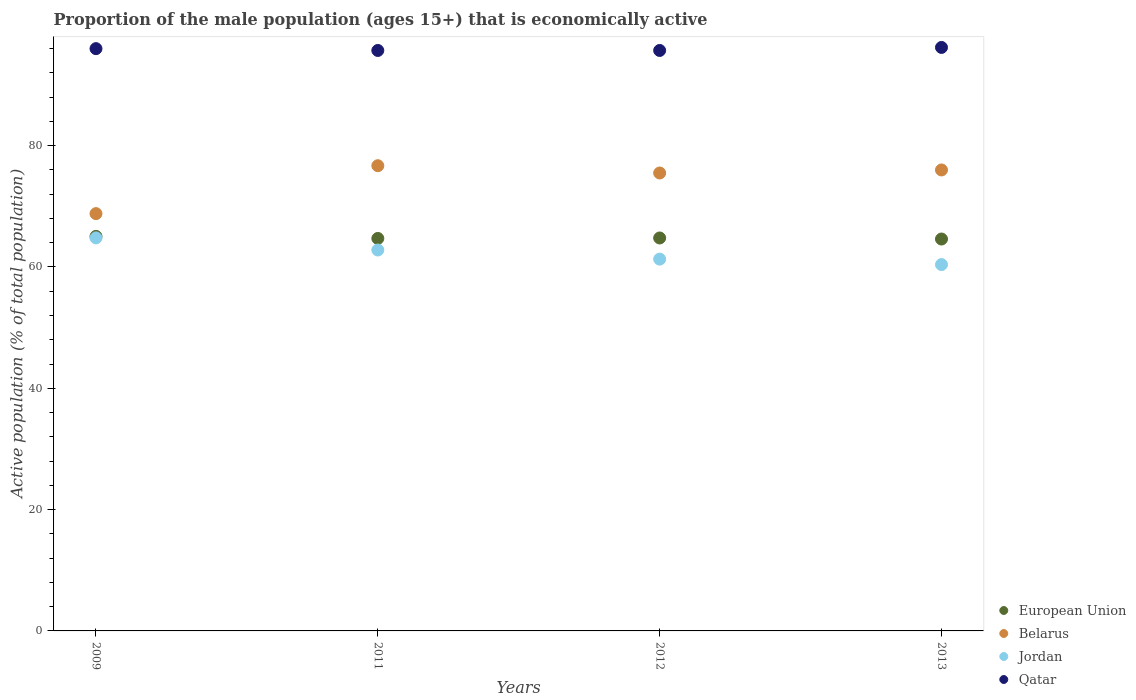How many different coloured dotlines are there?
Offer a terse response. 4. What is the proportion of the male population that is economically active in European Union in 2009?
Provide a succinct answer. 65.04. Across all years, what is the maximum proportion of the male population that is economically active in European Union?
Keep it short and to the point. 65.04. Across all years, what is the minimum proportion of the male population that is economically active in Qatar?
Provide a short and direct response. 95.7. What is the total proportion of the male population that is economically active in Jordan in the graph?
Provide a succinct answer. 249.3. What is the difference between the proportion of the male population that is economically active in Qatar in 2009 and that in 2011?
Your answer should be very brief. 0.3. What is the difference between the proportion of the male population that is economically active in Jordan in 2011 and the proportion of the male population that is economically active in European Union in 2009?
Provide a short and direct response. -2.24. What is the average proportion of the male population that is economically active in Belarus per year?
Provide a succinct answer. 74.25. In the year 2012, what is the difference between the proportion of the male population that is economically active in Qatar and proportion of the male population that is economically active in European Union?
Your answer should be compact. 30.92. What is the ratio of the proportion of the male population that is economically active in Qatar in 2011 to that in 2013?
Ensure brevity in your answer.  0.99. Is the difference between the proportion of the male population that is economically active in Qatar in 2011 and 2013 greater than the difference between the proportion of the male population that is economically active in European Union in 2011 and 2013?
Give a very brief answer. No. What is the difference between the highest and the second highest proportion of the male population that is economically active in European Union?
Offer a terse response. 0.26. What is the difference between the highest and the lowest proportion of the male population that is economically active in Jordan?
Your answer should be very brief. 4.4. Is it the case that in every year, the sum of the proportion of the male population that is economically active in European Union and proportion of the male population that is economically active in Belarus  is greater than the proportion of the male population that is economically active in Jordan?
Make the answer very short. Yes. Does the proportion of the male population that is economically active in European Union monotonically increase over the years?
Make the answer very short. No. Is the proportion of the male population that is economically active in Qatar strictly greater than the proportion of the male population that is economically active in European Union over the years?
Ensure brevity in your answer.  Yes. Is the proportion of the male population that is economically active in European Union strictly less than the proportion of the male population that is economically active in Qatar over the years?
Ensure brevity in your answer.  Yes. How many dotlines are there?
Offer a terse response. 4. How many years are there in the graph?
Provide a short and direct response. 4. Does the graph contain any zero values?
Provide a succinct answer. No. Where does the legend appear in the graph?
Keep it short and to the point. Bottom right. How many legend labels are there?
Make the answer very short. 4. How are the legend labels stacked?
Provide a short and direct response. Vertical. What is the title of the graph?
Make the answer very short. Proportion of the male population (ages 15+) that is economically active. Does "West Bank and Gaza" appear as one of the legend labels in the graph?
Offer a terse response. No. What is the label or title of the Y-axis?
Your response must be concise. Active population (% of total population). What is the Active population (% of total population) in European Union in 2009?
Your answer should be compact. 65.04. What is the Active population (% of total population) in Belarus in 2009?
Provide a short and direct response. 68.8. What is the Active population (% of total population) in Jordan in 2009?
Ensure brevity in your answer.  64.8. What is the Active population (% of total population) of Qatar in 2009?
Offer a terse response. 96. What is the Active population (% of total population) of European Union in 2011?
Give a very brief answer. 64.71. What is the Active population (% of total population) in Belarus in 2011?
Provide a short and direct response. 76.7. What is the Active population (% of total population) of Jordan in 2011?
Your response must be concise. 62.8. What is the Active population (% of total population) of Qatar in 2011?
Offer a terse response. 95.7. What is the Active population (% of total population) in European Union in 2012?
Provide a succinct answer. 64.78. What is the Active population (% of total population) in Belarus in 2012?
Keep it short and to the point. 75.5. What is the Active population (% of total population) of Jordan in 2012?
Your answer should be very brief. 61.3. What is the Active population (% of total population) in Qatar in 2012?
Your answer should be compact. 95.7. What is the Active population (% of total population) of European Union in 2013?
Make the answer very short. 64.61. What is the Active population (% of total population) of Jordan in 2013?
Make the answer very short. 60.4. What is the Active population (% of total population) of Qatar in 2013?
Keep it short and to the point. 96.2. Across all years, what is the maximum Active population (% of total population) in European Union?
Your answer should be very brief. 65.04. Across all years, what is the maximum Active population (% of total population) of Belarus?
Offer a very short reply. 76.7. Across all years, what is the maximum Active population (% of total population) in Jordan?
Your answer should be very brief. 64.8. Across all years, what is the maximum Active population (% of total population) in Qatar?
Provide a short and direct response. 96.2. Across all years, what is the minimum Active population (% of total population) of European Union?
Make the answer very short. 64.61. Across all years, what is the minimum Active population (% of total population) of Belarus?
Offer a very short reply. 68.8. Across all years, what is the minimum Active population (% of total population) in Jordan?
Ensure brevity in your answer.  60.4. Across all years, what is the minimum Active population (% of total population) in Qatar?
Keep it short and to the point. 95.7. What is the total Active population (% of total population) in European Union in the graph?
Your answer should be very brief. 259.15. What is the total Active population (% of total population) in Belarus in the graph?
Offer a terse response. 297. What is the total Active population (% of total population) of Jordan in the graph?
Make the answer very short. 249.3. What is the total Active population (% of total population) in Qatar in the graph?
Give a very brief answer. 383.6. What is the difference between the Active population (% of total population) in European Union in 2009 and that in 2011?
Provide a short and direct response. 0.34. What is the difference between the Active population (% of total population) in Belarus in 2009 and that in 2011?
Provide a succinct answer. -7.9. What is the difference between the Active population (% of total population) in Jordan in 2009 and that in 2011?
Your answer should be very brief. 2. What is the difference between the Active population (% of total population) of Qatar in 2009 and that in 2011?
Keep it short and to the point. 0.3. What is the difference between the Active population (% of total population) in European Union in 2009 and that in 2012?
Your answer should be compact. 0.26. What is the difference between the Active population (% of total population) of Belarus in 2009 and that in 2012?
Your answer should be very brief. -6.7. What is the difference between the Active population (% of total population) of Jordan in 2009 and that in 2012?
Offer a very short reply. 3.5. What is the difference between the Active population (% of total population) in European Union in 2009 and that in 2013?
Provide a short and direct response. 0.43. What is the difference between the Active population (% of total population) in Jordan in 2009 and that in 2013?
Your answer should be very brief. 4.4. What is the difference between the Active population (% of total population) of European Union in 2011 and that in 2012?
Your answer should be very brief. -0.08. What is the difference between the Active population (% of total population) in Belarus in 2011 and that in 2012?
Your answer should be very brief. 1.2. What is the difference between the Active population (% of total population) in European Union in 2011 and that in 2013?
Your answer should be very brief. 0.1. What is the difference between the Active population (% of total population) in Belarus in 2011 and that in 2013?
Your response must be concise. 0.7. What is the difference between the Active population (% of total population) in Jordan in 2011 and that in 2013?
Your answer should be compact. 2.4. What is the difference between the Active population (% of total population) of European Union in 2012 and that in 2013?
Offer a very short reply. 0.17. What is the difference between the Active population (% of total population) in Jordan in 2012 and that in 2013?
Provide a short and direct response. 0.9. What is the difference between the Active population (% of total population) in Qatar in 2012 and that in 2013?
Give a very brief answer. -0.5. What is the difference between the Active population (% of total population) in European Union in 2009 and the Active population (% of total population) in Belarus in 2011?
Ensure brevity in your answer.  -11.66. What is the difference between the Active population (% of total population) in European Union in 2009 and the Active population (% of total population) in Jordan in 2011?
Provide a short and direct response. 2.24. What is the difference between the Active population (% of total population) of European Union in 2009 and the Active population (% of total population) of Qatar in 2011?
Give a very brief answer. -30.66. What is the difference between the Active population (% of total population) of Belarus in 2009 and the Active population (% of total population) of Qatar in 2011?
Your answer should be compact. -26.9. What is the difference between the Active population (% of total population) in Jordan in 2009 and the Active population (% of total population) in Qatar in 2011?
Your response must be concise. -30.9. What is the difference between the Active population (% of total population) of European Union in 2009 and the Active population (% of total population) of Belarus in 2012?
Offer a very short reply. -10.46. What is the difference between the Active population (% of total population) in European Union in 2009 and the Active population (% of total population) in Jordan in 2012?
Your answer should be compact. 3.74. What is the difference between the Active population (% of total population) in European Union in 2009 and the Active population (% of total population) in Qatar in 2012?
Make the answer very short. -30.66. What is the difference between the Active population (% of total population) of Belarus in 2009 and the Active population (% of total population) of Jordan in 2012?
Your answer should be compact. 7.5. What is the difference between the Active population (% of total population) of Belarus in 2009 and the Active population (% of total population) of Qatar in 2012?
Offer a very short reply. -26.9. What is the difference between the Active population (% of total population) in Jordan in 2009 and the Active population (% of total population) in Qatar in 2012?
Your answer should be very brief. -30.9. What is the difference between the Active population (% of total population) in European Union in 2009 and the Active population (% of total population) in Belarus in 2013?
Your answer should be compact. -10.96. What is the difference between the Active population (% of total population) in European Union in 2009 and the Active population (% of total population) in Jordan in 2013?
Provide a short and direct response. 4.64. What is the difference between the Active population (% of total population) in European Union in 2009 and the Active population (% of total population) in Qatar in 2013?
Give a very brief answer. -31.16. What is the difference between the Active population (% of total population) in Belarus in 2009 and the Active population (% of total population) in Jordan in 2013?
Give a very brief answer. 8.4. What is the difference between the Active population (% of total population) in Belarus in 2009 and the Active population (% of total population) in Qatar in 2013?
Ensure brevity in your answer.  -27.4. What is the difference between the Active population (% of total population) in Jordan in 2009 and the Active population (% of total population) in Qatar in 2013?
Make the answer very short. -31.4. What is the difference between the Active population (% of total population) in European Union in 2011 and the Active population (% of total population) in Belarus in 2012?
Your response must be concise. -10.79. What is the difference between the Active population (% of total population) of European Union in 2011 and the Active population (% of total population) of Jordan in 2012?
Make the answer very short. 3.41. What is the difference between the Active population (% of total population) of European Union in 2011 and the Active population (% of total population) of Qatar in 2012?
Offer a very short reply. -30.99. What is the difference between the Active population (% of total population) in Belarus in 2011 and the Active population (% of total population) in Jordan in 2012?
Keep it short and to the point. 15.4. What is the difference between the Active population (% of total population) in Jordan in 2011 and the Active population (% of total population) in Qatar in 2012?
Your answer should be compact. -32.9. What is the difference between the Active population (% of total population) of European Union in 2011 and the Active population (% of total population) of Belarus in 2013?
Your answer should be compact. -11.29. What is the difference between the Active population (% of total population) in European Union in 2011 and the Active population (% of total population) in Jordan in 2013?
Give a very brief answer. 4.31. What is the difference between the Active population (% of total population) of European Union in 2011 and the Active population (% of total population) of Qatar in 2013?
Offer a very short reply. -31.49. What is the difference between the Active population (% of total population) of Belarus in 2011 and the Active population (% of total population) of Qatar in 2013?
Provide a short and direct response. -19.5. What is the difference between the Active population (% of total population) in Jordan in 2011 and the Active population (% of total population) in Qatar in 2013?
Provide a short and direct response. -33.4. What is the difference between the Active population (% of total population) of European Union in 2012 and the Active population (% of total population) of Belarus in 2013?
Your answer should be very brief. -11.22. What is the difference between the Active population (% of total population) of European Union in 2012 and the Active population (% of total population) of Jordan in 2013?
Give a very brief answer. 4.38. What is the difference between the Active population (% of total population) in European Union in 2012 and the Active population (% of total population) in Qatar in 2013?
Provide a short and direct response. -31.42. What is the difference between the Active population (% of total population) in Belarus in 2012 and the Active population (% of total population) in Qatar in 2013?
Provide a succinct answer. -20.7. What is the difference between the Active population (% of total population) of Jordan in 2012 and the Active population (% of total population) of Qatar in 2013?
Your answer should be very brief. -34.9. What is the average Active population (% of total population) of European Union per year?
Make the answer very short. 64.79. What is the average Active population (% of total population) of Belarus per year?
Offer a terse response. 74.25. What is the average Active population (% of total population) in Jordan per year?
Keep it short and to the point. 62.33. What is the average Active population (% of total population) in Qatar per year?
Make the answer very short. 95.9. In the year 2009, what is the difference between the Active population (% of total population) in European Union and Active population (% of total population) in Belarus?
Keep it short and to the point. -3.76. In the year 2009, what is the difference between the Active population (% of total population) of European Union and Active population (% of total population) of Jordan?
Keep it short and to the point. 0.24. In the year 2009, what is the difference between the Active population (% of total population) of European Union and Active population (% of total population) of Qatar?
Your answer should be compact. -30.96. In the year 2009, what is the difference between the Active population (% of total population) of Belarus and Active population (% of total population) of Qatar?
Provide a succinct answer. -27.2. In the year 2009, what is the difference between the Active population (% of total population) in Jordan and Active population (% of total population) in Qatar?
Ensure brevity in your answer.  -31.2. In the year 2011, what is the difference between the Active population (% of total population) in European Union and Active population (% of total population) in Belarus?
Your answer should be very brief. -11.99. In the year 2011, what is the difference between the Active population (% of total population) of European Union and Active population (% of total population) of Jordan?
Give a very brief answer. 1.91. In the year 2011, what is the difference between the Active population (% of total population) in European Union and Active population (% of total population) in Qatar?
Offer a terse response. -30.99. In the year 2011, what is the difference between the Active population (% of total population) of Belarus and Active population (% of total population) of Jordan?
Give a very brief answer. 13.9. In the year 2011, what is the difference between the Active population (% of total population) of Jordan and Active population (% of total population) of Qatar?
Give a very brief answer. -32.9. In the year 2012, what is the difference between the Active population (% of total population) of European Union and Active population (% of total population) of Belarus?
Provide a succinct answer. -10.72. In the year 2012, what is the difference between the Active population (% of total population) in European Union and Active population (% of total population) in Jordan?
Make the answer very short. 3.48. In the year 2012, what is the difference between the Active population (% of total population) of European Union and Active population (% of total population) of Qatar?
Make the answer very short. -30.92. In the year 2012, what is the difference between the Active population (% of total population) of Belarus and Active population (% of total population) of Qatar?
Provide a succinct answer. -20.2. In the year 2012, what is the difference between the Active population (% of total population) of Jordan and Active population (% of total population) of Qatar?
Your answer should be compact. -34.4. In the year 2013, what is the difference between the Active population (% of total population) of European Union and Active population (% of total population) of Belarus?
Keep it short and to the point. -11.39. In the year 2013, what is the difference between the Active population (% of total population) of European Union and Active population (% of total population) of Jordan?
Provide a succinct answer. 4.21. In the year 2013, what is the difference between the Active population (% of total population) in European Union and Active population (% of total population) in Qatar?
Ensure brevity in your answer.  -31.59. In the year 2013, what is the difference between the Active population (% of total population) of Belarus and Active population (% of total population) of Jordan?
Make the answer very short. 15.6. In the year 2013, what is the difference between the Active population (% of total population) in Belarus and Active population (% of total population) in Qatar?
Offer a terse response. -20.2. In the year 2013, what is the difference between the Active population (% of total population) in Jordan and Active population (% of total population) in Qatar?
Your answer should be very brief. -35.8. What is the ratio of the Active population (% of total population) in Belarus in 2009 to that in 2011?
Provide a succinct answer. 0.9. What is the ratio of the Active population (% of total population) in Jordan in 2009 to that in 2011?
Your answer should be very brief. 1.03. What is the ratio of the Active population (% of total population) of Qatar in 2009 to that in 2011?
Give a very brief answer. 1. What is the ratio of the Active population (% of total population) in Belarus in 2009 to that in 2012?
Provide a short and direct response. 0.91. What is the ratio of the Active population (% of total population) of Jordan in 2009 to that in 2012?
Provide a succinct answer. 1.06. What is the ratio of the Active population (% of total population) in Qatar in 2009 to that in 2012?
Provide a succinct answer. 1. What is the ratio of the Active population (% of total population) in Belarus in 2009 to that in 2013?
Offer a terse response. 0.91. What is the ratio of the Active population (% of total population) of Jordan in 2009 to that in 2013?
Give a very brief answer. 1.07. What is the ratio of the Active population (% of total population) in European Union in 2011 to that in 2012?
Offer a terse response. 1. What is the ratio of the Active population (% of total population) of Belarus in 2011 to that in 2012?
Provide a succinct answer. 1.02. What is the ratio of the Active population (% of total population) in Jordan in 2011 to that in 2012?
Make the answer very short. 1.02. What is the ratio of the Active population (% of total population) of European Union in 2011 to that in 2013?
Give a very brief answer. 1. What is the ratio of the Active population (% of total population) of Belarus in 2011 to that in 2013?
Provide a short and direct response. 1.01. What is the ratio of the Active population (% of total population) in Jordan in 2011 to that in 2013?
Offer a terse response. 1.04. What is the ratio of the Active population (% of total population) of Qatar in 2011 to that in 2013?
Keep it short and to the point. 0.99. What is the ratio of the Active population (% of total population) of Jordan in 2012 to that in 2013?
Make the answer very short. 1.01. What is the ratio of the Active population (% of total population) of Qatar in 2012 to that in 2013?
Make the answer very short. 0.99. What is the difference between the highest and the second highest Active population (% of total population) of European Union?
Offer a terse response. 0.26. What is the difference between the highest and the second highest Active population (% of total population) in Qatar?
Your answer should be very brief. 0.2. What is the difference between the highest and the lowest Active population (% of total population) of European Union?
Provide a succinct answer. 0.43. 